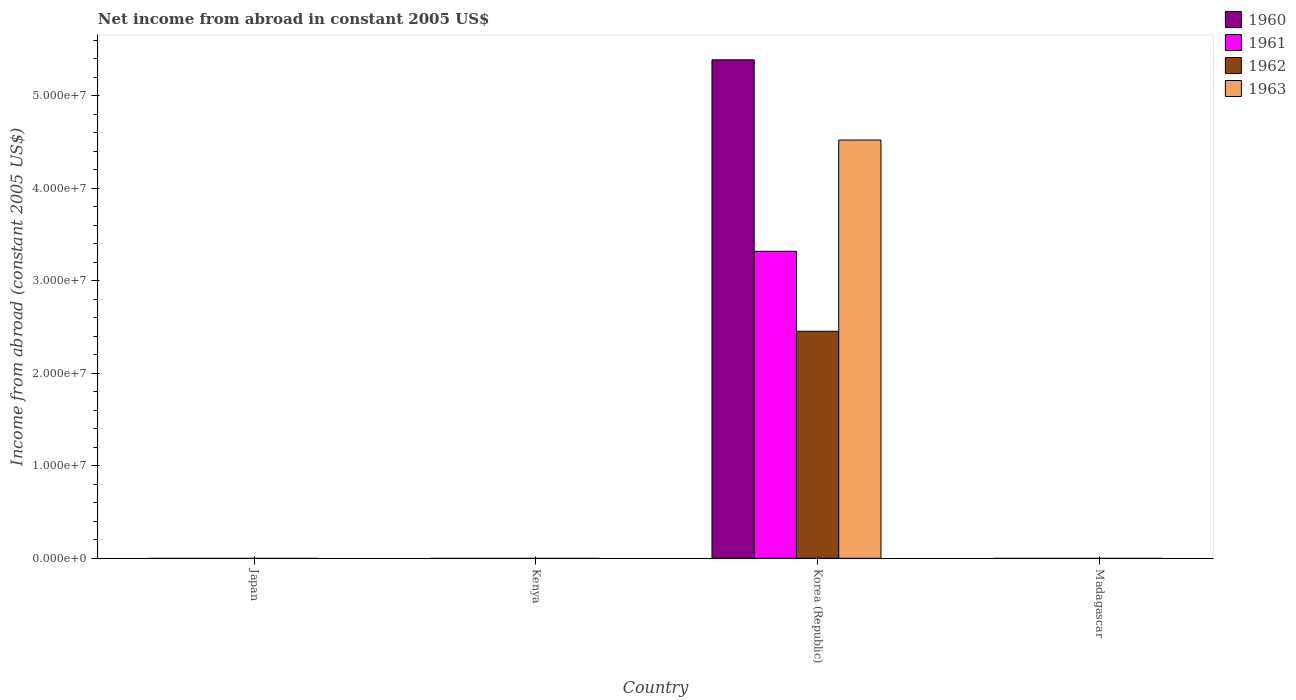Are the number of bars per tick equal to the number of legend labels?
Your answer should be very brief. No. Are the number of bars on each tick of the X-axis equal?
Your response must be concise. No. How many bars are there on the 3rd tick from the left?
Offer a very short reply. 4. What is the label of the 2nd group of bars from the left?
Make the answer very short. Kenya. In how many cases, is the number of bars for a given country not equal to the number of legend labels?
Provide a succinct answer. 3. What is the net income from abroad in 1963 in Japan?
Your response must be concise. 0. Across all countries, what is the maximum net income from abroad in 1960?
Offer a very short reply. 5.39e+07. Across all countries, what is the minimum net income from abroad in 1961?
Offer a very short reply. 0. What is the total net income from abroad in 1961 in the graph?
Give a very brief answer. 3.32e+07. What is the average net income from abroad in 1960 per country?
Offer a terse response. 1.35e+07. What is the difference between the net income from abroad of/in 1960 and net income from abroad of/in 1963 in Korea (Republic)?
Provide a short and direct response. 8.68e+06. What is the difference between the highest and the lowest net income from abroad in 1960?
Ensure brevity in your answer.  5.39e+07. In how many countries, is the net income from abroad in 1962 greater than the average net income from abroad in 1962 taken over all countries?
Give a very brief answer. 1. How many bars are there?
Provide a succinct answer. 4. Are all the bars in the graph horizontal?
Keep it short and to the point. No. How many countries are there in the graph?
Make the answer very short. 4. What is the difference between two consecutive major ticks on the Y-axis?
Your answer should be compact. 1.00e+07. Does the graph contain any zero values?
Keep it short and to the point. Yes. How many legend labels are there?
Keep it short and to the point. 4. How are the legend labels stacked?
Provide a short and direct response. Vertical. What is the title of the graph?
Keep it short and to the point. Net income from abroad in constant 2005 US$. What is the label or title of the Y-axis?
Give a very brief answer. Income from abroad (constant 2005 US$). What is the Income from abroad (constant 2005 US$) in 1961 in Japan?
Provide a short and direct response. 0. What is the Income from abroad (constant 2005 US$) in 1962 in Japan?
Give a very brief answer. 0. What is the Income from abroad (constant 2005 US$) in 1963 in Japan?
Provide a succinct answer. 0. What is the Income from abroad (constant 2005 US$) in 1960 in Kenya?
Ensure brevity in your answer.  0. What is the Income from abroad (constant 2005 US$) in 1962 in Kenya?
Provide a short and direct response. 0. What is the Income from abroad (constant 2005 US$) of 1960 in Korea (Republic)?
Offer a very short reply. 5.39e+07. What is the Income from abroad (constant 2005 US$) in 1961 in Korea (Republic)?
Provide a short and direct response. 3.32e+07. What is the Income from abroad (constant 2005 US$) of 1962 in Korea (Republic)?
Provide a succinct answer. 2.45e+07. What is the Income from abroad (constant 2005 US$) in 1963 in Korea (Republic)?
Keep it short and to the point. 4.52e+07. What is the Income from abroad (constant 2005 US$) in 1962 in Madagascar?
Provide a short and direct response. 0. Across all countries, what is the maximum Income from abroad (constant 2005 US$) of 1960?
Offer a terse response. 5.39e+07. Across all countries, what is the maximum Income from abroad (constant 2005 US$) of 1961?
Provide a short and direct response. 3.32e+07. Across all countries, what is the maximum Income from abroad (constant 2005 US$) in 1962?
Ensure brevity in your answer.  2.45e+07. Across all countries, what is the maximum Income from abroad (constant 2005 US$) in 1963?
Keep it short and to the point. 4.52e+07. Across all countries, what is the minimum Income from abroad (constant 2005 US$) in 1960?
Offer a terse response. 0. Across all countries, what is the minimum Income from abroad (constant 2005 US$) in 1961?
Offer a terse response. 0. Across all countries, what is the minimum Income from abroad (constant 2005 US$) of 1962?
Your response must be concise. 0. Across all countries, what is the minimum Income from abroad (constant 2005 US$) of 1963?
Keep it short and to the point. 0. What is the total Income from abroad (constant 2005 US$) in 1960 in the graph?
Provide a short and direct response. 5.39e+07. What is the total Income from abroad (constant 2005 US$) of 1961 in the graph?
Your answer should be compact. 3.32e+07. What is the total Income from abroad (constant 2005 US$) in 1962 in the graph?
Provide a succinct answer. 2.45e+07. What is the total Income from abroad (constant 2005 US$) in 1963 in the graph?
Ensure brevity in your answer.  4.52e+07. What is the average Income from abroad (constant 2005 US$) of 1960 per country?
Ensure brevity in your answer.  1.35e+07. What is the average Income from abroad (constant 2005 US$) of 1961 per country?
Your answer should be very brief. 8.30e+06. What is the average Income from abroad (constant 2005 US$) in 1962 per country?
Offer a terse response. 6.14e+06. What is the average Income from abroad (constant 2005 US$) of 1963 per country?
Your answer should be very brief. 1.13e+07. What is the difference between the Income from abroad (constant 2005 US$) in 1960 and Income from abroad (constant 2005 US$) in 1961 in Korea (Republic)?
Offer a terse response. 2.07e+07. What is the difference between the Income from abroad (constant 2005 US$) in 1960 and Income from abroad (constant 2005 US$) in 1962 in Korea (Republic)?
Ensure brevity in your answer.  2.94e+07. What is the difference between the Income from abroad (constant 2005 US$) of 1960 and Income from abroad (constant 2005 US$) of 1963 in Korea (Republic)?
Give a very brief answer. 8.68e+06. What is the difference between the Income from abroad (constant 2005 US$) of 1961 and Income from abroad (constant 2005 US$) of 1962 in Korea (Republic)?
Your answer should be very brief. 8.65e+06. What is the difference between the Income from abroad (constant 2005 US$) in 1961 and Income from abroad (constant 2005 US$) in 1963 in Korea (Republic)?
Offer a terse response. -1.20e+07. What is the difference between the Income from abroad (constant 2005 US$) of 1962 and Income from abroad (constant 2005 US$) of 1963 in Korea (Republic)?
Your answer should be very brief. -2.07e+07. What is the difference between the highest and the lowest Income from abroad (constant 2005 US$) in 1960?
Ensure brevity in your answer.  5.39e+07. What is the difference between the highest and the lowest Income from abroad (constant 2005 US$) of 1961?
Provide a short and direct response. 3.32e+07. What is the difference between the highest and the lowest Income from abroad (constant 2005 US$) in 1962?
Ensure brevity in your answer.  2.45e+07. What is the difference between the highest and the lowest Income from abroad (constant 2005 US$) of 1963?
Offer a terse response. 4.52e+07. 